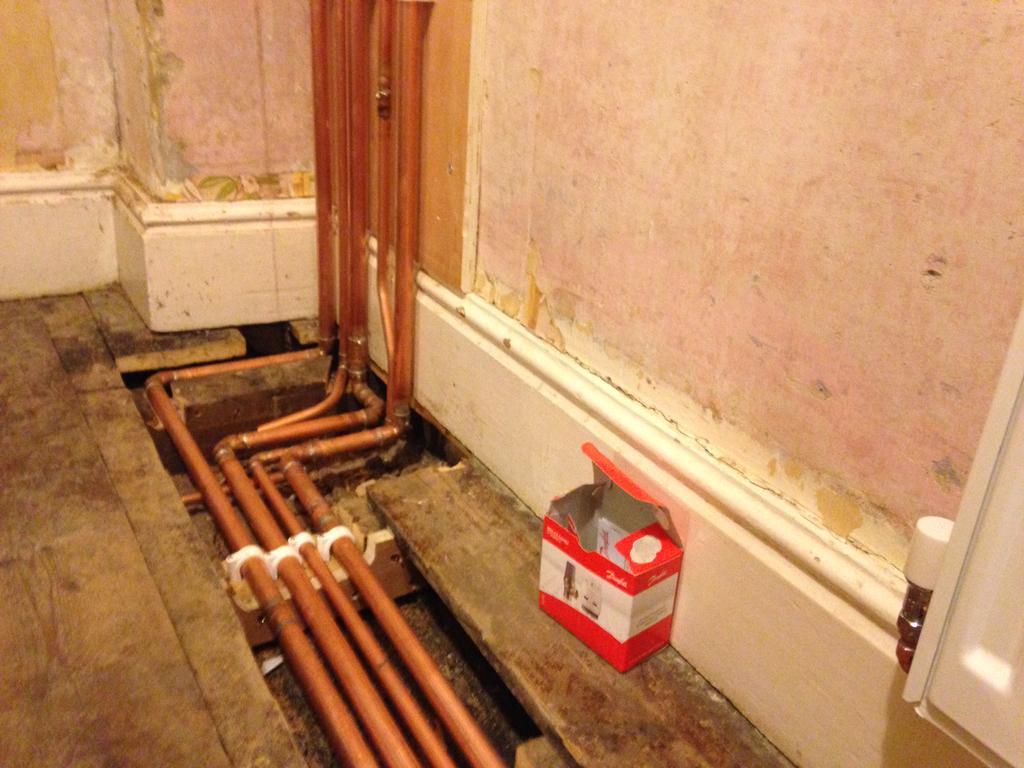In one or two sentences, can you explain what this image depicts? In this image in the front there are pipes and on the right side there is a box and there is a wall and on the wall there is a cupboard. 